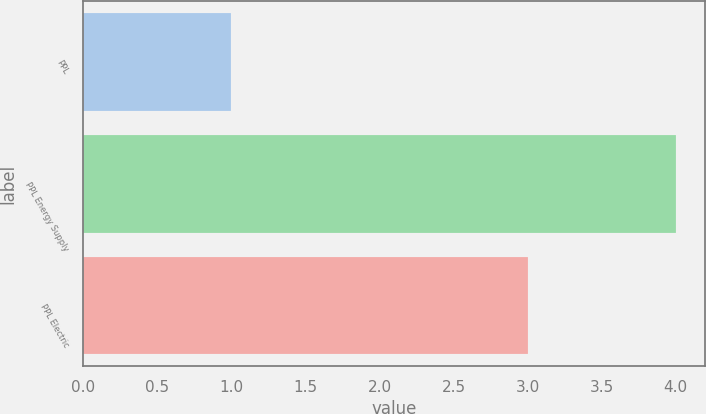<chart> <loc_0><loc_0><loc_500><loc_500><bar_chart><fcel>PPL<fcel>PPL Energy Supply<fcel>PPL Electric<nl><fcel>1<fcel>4<fcel>3<nl></chart> 